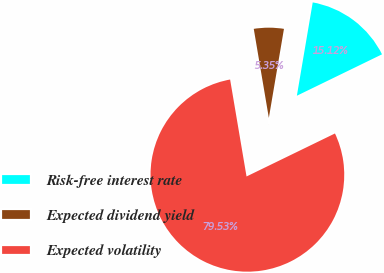Convert chart to OTSL. <chart><loc_0><loc_0><loc_500><loc_500><pie_chart><fcel>Risk-free interest rate<fcel>Expected dividend yield<fcel>Expected volatility<nl><fcel>15.12%<fcel>5.35%<fcel>79.54%<nl></chart> 